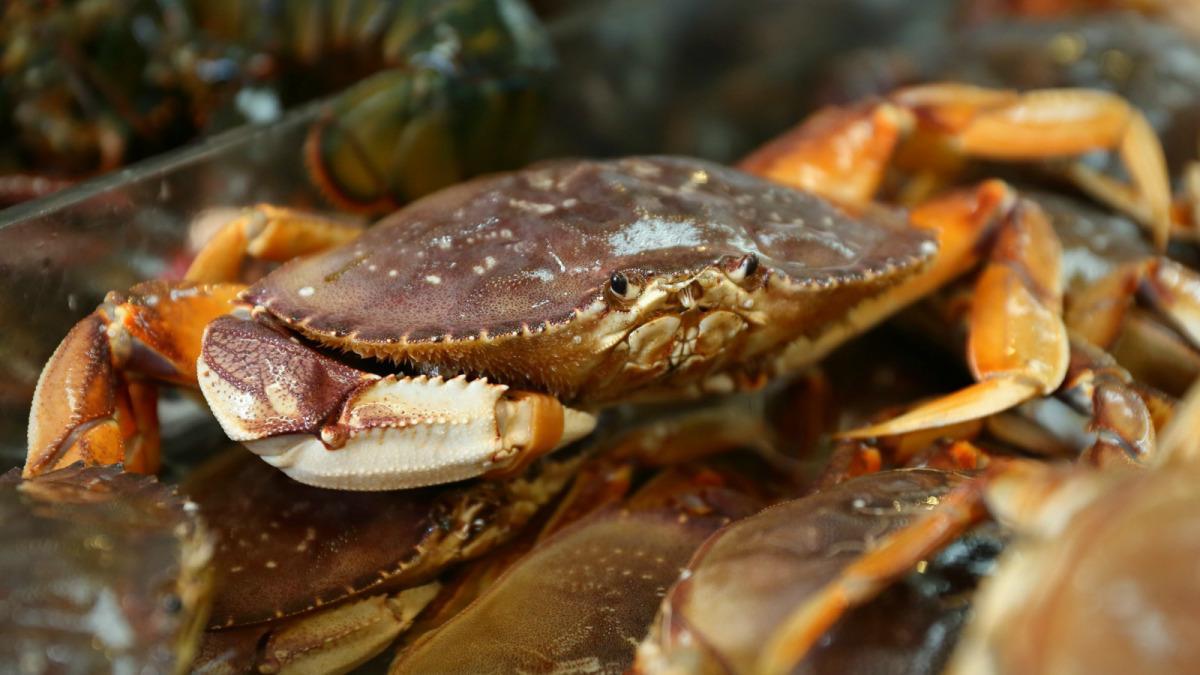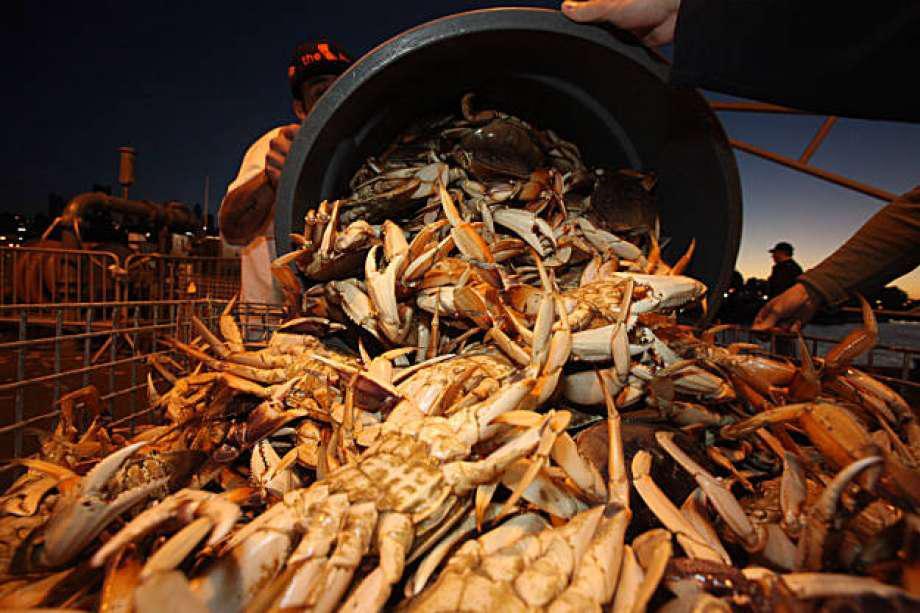The first image is the image on the left, the second image is the image on the right. Analyze the images presented: Is the assertion "All the crabs are piled on top of one another." valid? Answer yes or no. Yes. The first image is the image on the left, the second image is the image on the right. Considering the images on both sides, is "In the right image, a white rectangular label is overlapping a red-orange-shelled crab that is in some type of container." valid? Answer yes or no. No. 